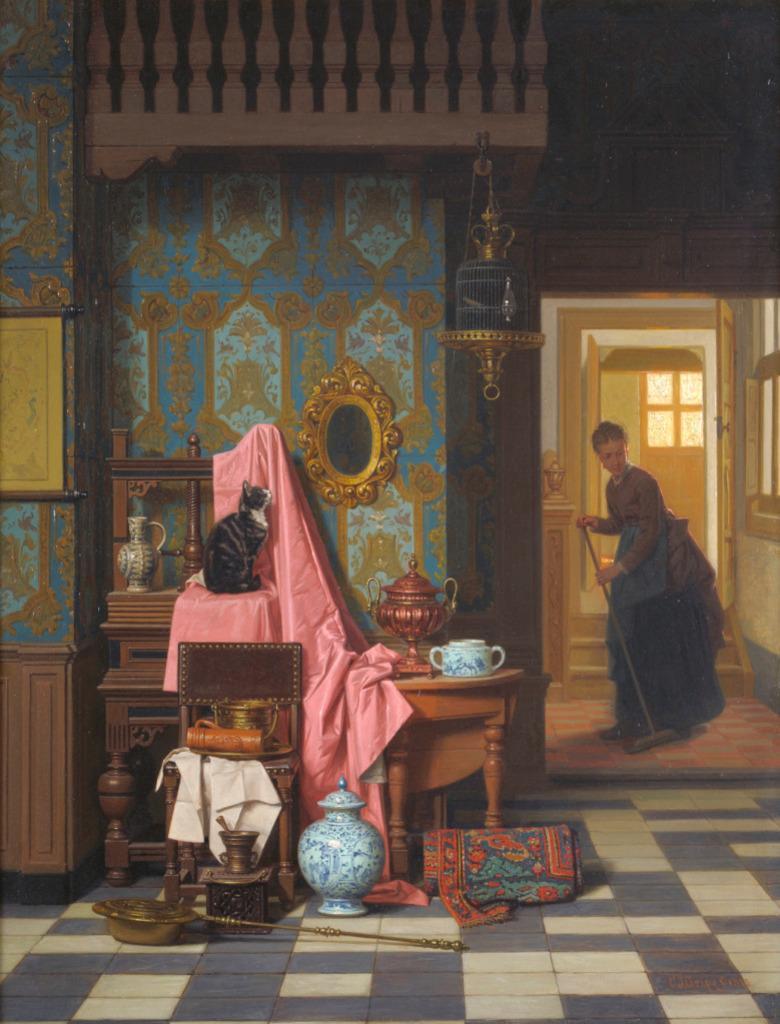Could you give a brief overview of what you see in this image? On the right side there is a lady holding a broom and cleaning the floor. On the left side there is a wall. On that there is a framed, mirror. Also there are tables. On one table there is a cloth. On that there is a cat. There is another table. On that there is a kettle and some other vessel. Also there is a chair. On that there is a cloth and some other thing. On the floor there is a cloth, pot and some other things. On the wall there is a wallpaper. And a cage is hanged on the railings on the top. 